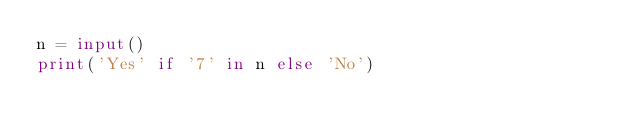Convert code to text. <code><loc_0><loc_0><loc_500><loc_500><_Python_>n = input()
print('Yes' if '7' in n else 'No')</code> 